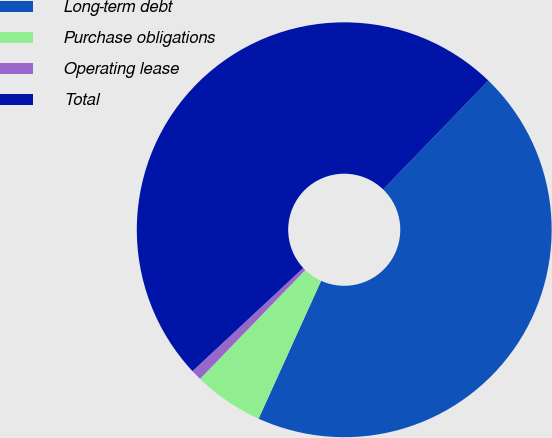Convert chart. <chart><loc_0><loc_0><loc_500><loc_500><pie_chart><fcel>Long-term debt<fcel>Purchase obligations<fcel>Operating lease<fcel>Total<nl><fcel>44.54%<fcel>5.46%<fcel>0.83%<fcel>49.17%<nl></chart> 